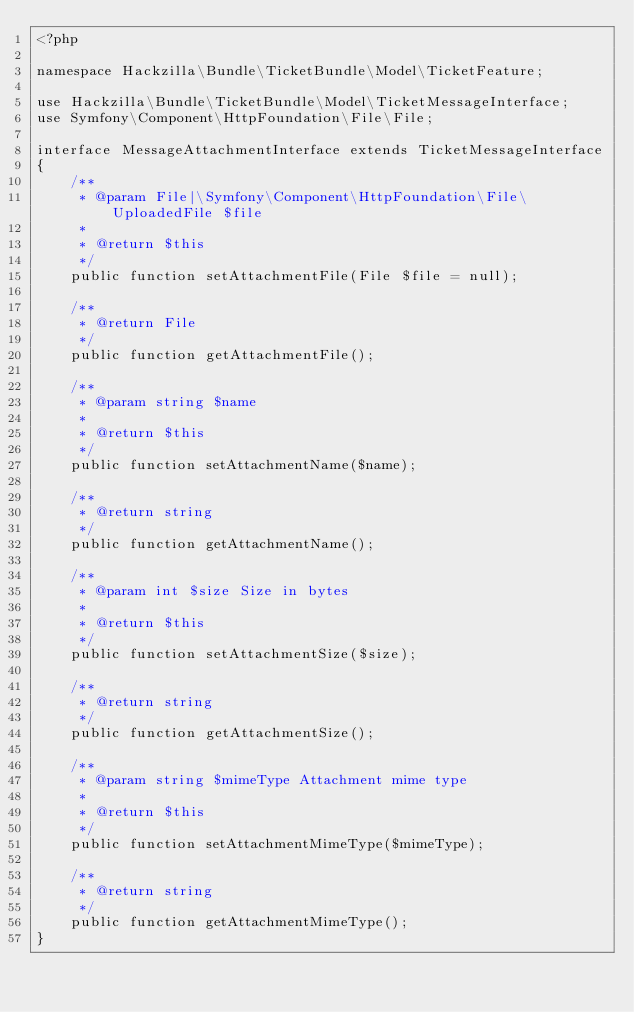<code> <loc_0><loc_0><loc_500><loc_500><_PHP_><?php

namespace Hackzilla\Bundle\TicketBundle\Model\TicketFeature;

use Hackzilla\Bundle\TicketBundle\Model\TicketMessageInterface;
use Symfony\Component\HttpFoundation\File\File;

interface MessageAttachmentInterface extends TicketMessageInterface
{
    /**
     * @param File|\Symfony\Component\HttpFoundation\File\UploadedFile $file
     *
     * @return $this
     */
    public function setAttachmentFile(File $file = null);

    /**
     * @return File
     */
    public function getAttachmentFile();

    /**
     * @param string $name
     *
     * @return $this
     */
    public function setAttachmentName($name);

    /**
     * @return string
     */
    public function getAttachmentName();

    /**
     * @param int $size Size in bytes
     *
     * @return $this
     */
    public function setAttachmentSize($size);

    /**
     * @return string
     */
    public function getAttachmentSize();

    /**
     * @param string $mimeType Attachment mime type
     *
     * @return $this
     */
    public function setAttachmentMimeType($mimeType);

    /**
     * @return string
     */
    public function getAttachmentMimeType();
}
</code> 